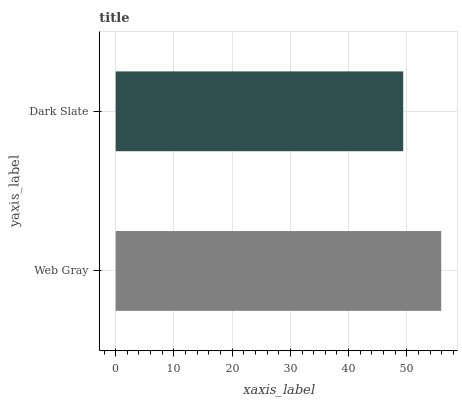Is Dark Slate the minimum?
Answer yes or no. Yes. Is Web Gray the maximum?
Answer yes or no. Yes. Is Dark Slate the maximum?
Answer yes or no. No. Is Web Gray greater than Dark Slate?
Answer yes or no. Yes. Is Dark Slate less than Web Gray?
Answer yes or no. Yes. Is Dark Slate greater than Web Gray?
Answer yes or no. No. Is Web Gray less than Dark Slate?
Answer yes or no. No. Is Web Gray the high median?
Answer yes or no. Yes. Is Dark Slate the low median?
Answer yes or no. Yes. Is Dark Slate the high median?
Answer yes or no. No. Is Web Gray the low median?
Answer yes or no. No. 